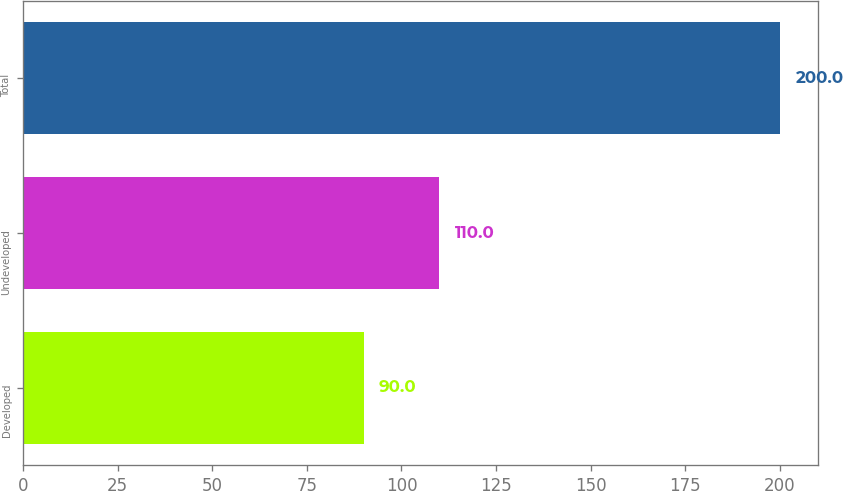<chart> <loc_0><loc_0><loc_500><loc_500><bar_chart><fcel>Developed<fcel>Undeveloped<fcel>Total<nl><fcel>90<fcel>110<fcel>200<nl></chart> 